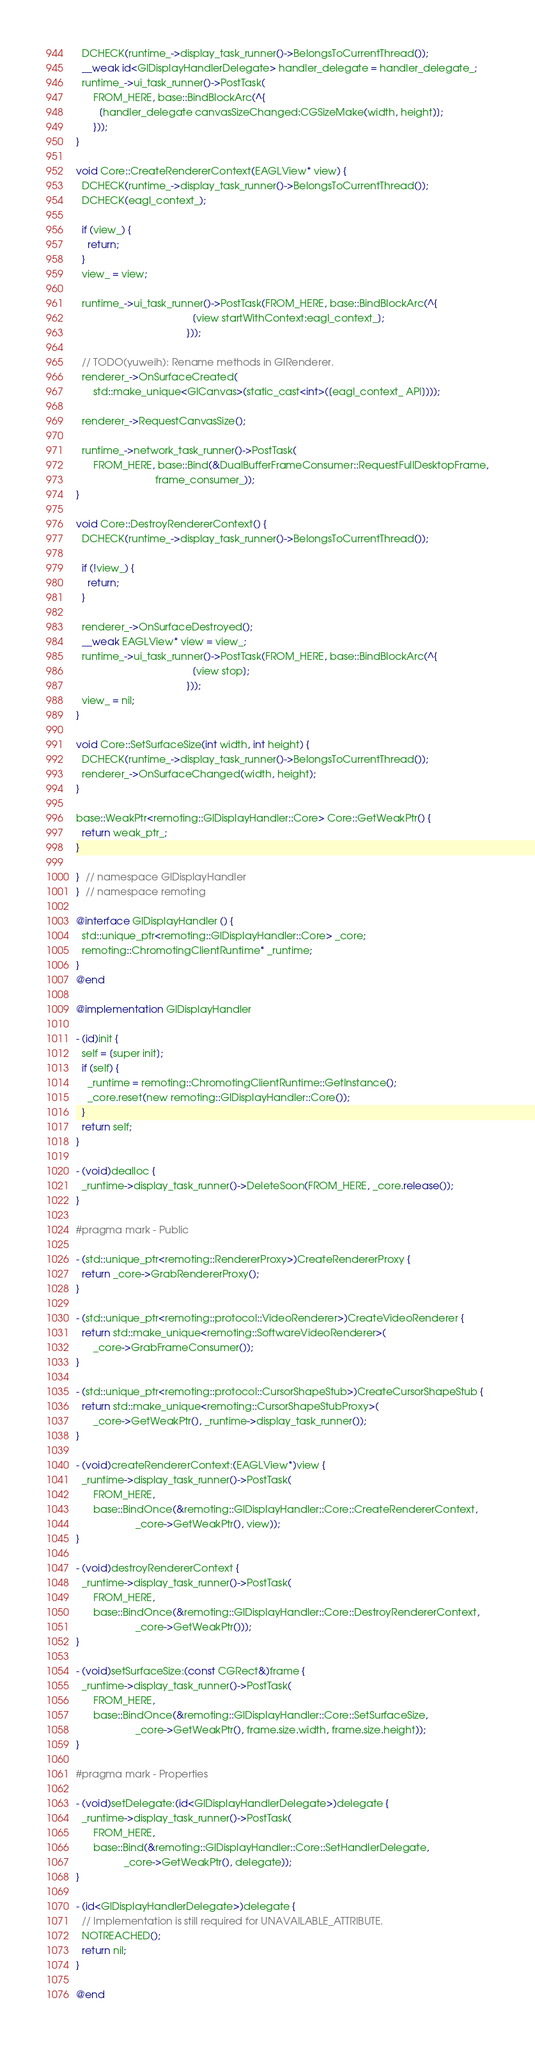Convert code to text. <code><loc_0><loc_0><loc_500><loc_500><_ObjectiveC_>  DCHECK(runtime_->display_task_runner()->BelongsToCurrentThread());
  __weak id<GlDisplayHandlerDelegate> handler_delegate = handler_delegate_;
  runtime_->ui_task_runner()->PostTask(
      FROM_HERE, base::BindBlockArc(^{
        [handler_delegate canvasSizeChanged:CGSizeMake(width, height)];
      }));
}

void Core::CreateRendererContext(EAGLView* view) {
  DCHECK(runtime_->display_task_runner()->BelongsToCurrentThread());
  DCHECK(eagl_context_);

  if (view_) {
    return;
  }
  view_ = view;

  runtime_->ui_task_runner()->PostTask(FROM_HERE, base::BindBlockArc(^{
                                         [view startWithContext:eagl_context_];
                                       }));

  // TODO(yuweih): Rename methods in GlRenderer.
  renderer_->OnSurfaceCreated(
      std::make_unique<GlCanvas>(static_cast<int>([eagl_context_ API])));

  renderer_->RequestCanvasSize();

  runtime_->network_task_runner()->PostTask(
      FROM_HERE, base::Bind(&DualBufferFrameConsumer::RequestFullDesktopFrame,
                            frame_consumer_));
}

void Core::DestroyRendererContext() {
  DCHECK(runtime_->display_task_runner()->BelongsToCurrentThread());

  if (!view_) {
    return;
  }

  renderer_->OnSurfaceDestroyed();
  __weak EAGLView* view = view_;
  runtime_->ui_task_runner()->PostTask(FROM_HERE, base::BindBlockArc(^{
                                         [view stop];
                                       }));
  view_ = nil;
}

void Core::SetSurfaceSize(int width, int height) {
  DCHECK(runtime_->display_task_runner()->BelongsToCurrentThread());
  renderer_->OnSurfaceChanged(width, height);
}

base::WeakPtr<remoting::GlDisplayHandler::Core> Core::GetWeakPtr() {
  return weak_ptr_;
}

}  // namespace GlDisplayHandler
}  // namespace remoting

@interface GlDisplayHandler () {
  std::unique_ptr<remoting::GlDisplayHandler::Core> _core;
  remoting::ChromotingClientRuntime* _runtime;
}
@end

@implementation GlDisplayHandler

- (id)init {
  self = [super init];
  if (self) {
    _runtime = remoting::ChromotingClientRuntime::GetInstance();
    _core.reset(new remoting::GlDisplayHandler::Core());
  }
  return self;
}

- (void)dealloc {
  _runtime->display_task_runner()->DeleteSoon(FROM_HERE, _core.release());
}

#pragma mark - Public

- (std::unique_ptr<remoting::RendererProxy>)CreateRendererProxy {
  return _core->GrabRendererProxy();
}

- (std::unique_ptr<remoting::protocol::VideoRenderer>)CreateVideoRenderer {
  return std::make_unique<remoting::SoftwareVideoRenderer>(
      _core->GrabFrameConsumer());
}

- (std::unique_ptr<remoting::protocol::CursorShapeStub>)CreateCursorShapeStub {
  return std::make_unique<remoting::CursorShapeStubProxy>(
      _core->GetWeakPtr(), _runtime->display_task_runner());
}

- (void)createRendererContext:(EAGLView*)view {
  _runtime->display_task_runner()->PostTask(
      FROM_HERE,
      base::BindOnce(&remoting::GlDisplayHandler::Core::CreateRendererContext,
                     _core->GetWeakPtr(), view));
}

- (void)destroyRendererContext {
  _runtime->display_task_runner()->PostTask(
      FROM_HERE,
      base::BindOnce(&remoting::GlDisplayHandler::Core::DestroyRendererContext,
                     _core->GetWeakPtr()));
}

- (void)setSurfaceSize:(const CGRect&)frame {
  _runtime->display_task_runner()->PostTask(
      FROM_HERE,
      base::BindOnce(&remoting::GlDisplayHandler::Core::SetSurfaceSize,
                     _core->GetWeakPtr(), frame.size.width, frame.size.height));
}

#pragma mark - Properties

- (void)setDelegate:(id<GlDisplayHandlerDelegate>)delegate {
  _runtime->display_task_runner()->PostTask(
      FROM_HERE,
      base::Bind(&remoting::GlDisplayHandler::Core::SetHandlerDelegate,
                 _core->GetWeakPtr(), delegate));
}

- (id<GlDisplayHandlerDelegate>)delegate {
  // Implementation is still required for UNAVAILABLE_ATTRIBUTE.
  NOTREACHED();
  return nil;
}

@end
</code> 